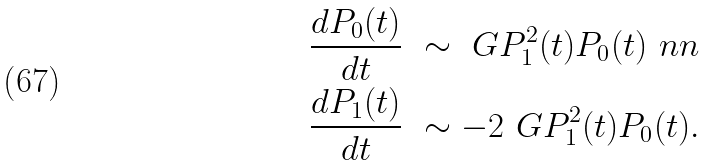Convert formula to latex. <formula><loc_0><loc_0><loc_500><loc_500>& \frac { d P _ { 0 } ( t ) } { d t } \ \sim \ G P _ { 1 } ^ { 2 } ( t ) P _ { 0 } ( t ) \ n n \\ & \frac { d P _ { 1 } ( t ) } { d t } \ \sim - 2 \ G P _ { 1 } ^ { 2 } ( t ) P _ { 0 } ( t ) .</formula> 